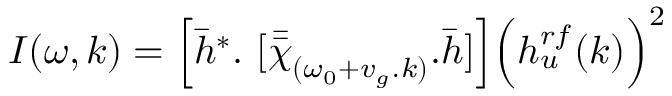Convert formula to latex. <formula><loc_0><loc_0><loc_500><loc_500>I ( \omega , k ) = \left [ \bar { h } ^ { * } . [ \bar { \bar { \chi } } _ { ( \omega _ { 0 } + v _ { g } . k ) } . \bar { h } ] \right ] \left ( h _ { u } ^ { r f } ( k ) \right ) ^ { 2 }</formula> 